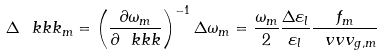Convert formula to latex. <formula><loc_0><loc_0><loc_500><loc_500>\Delta \ k k k _ { m } = \left ( \frac { \partial \omega _ { m } } { \partial \ k k k } \right ) ^ { - 1 } \Delta \omega _ { m } = \frac { \omega _ { m } } { 2 } \frac { \Delta \varepsilon _ { l } } { \varepsilon _ { l } } \frac { f _ { m } } { \ v v v _ { g , m } }</formula> 